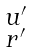<formula> <loc_0><loc_0><loc_500><loc_500>\begin{smallmatrix} u ^ { \prime } \\ r ^ { \prime } \end{smallmatrix}</formula> 